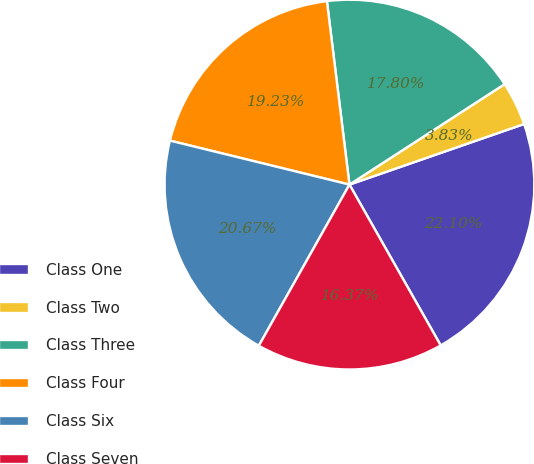Convert chart to OTSL. <chart><loc_0><loc_0><loc_500><loc_500><pie_chart><fcel>Class One<fcel>Class Two<fcel>Class Three<fcel>Class Four<fcel>Class Six<fcel>Class Seven<nl><fcel>22.1%<fcel>3.83%<fcel>17.8%<fcel>19.23%<fcel>20.67%<fcel>16.37%<nl></chart> 